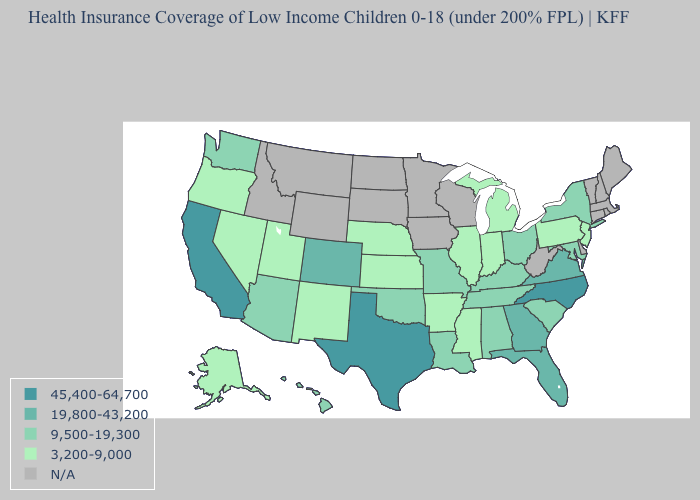How many symbols are there in the legend?
Short answer required. 5. What is the lowest value in the Northeast?
Be succinct. 3,200-9,000. Among the states that border Oklahoma , does Arkansas have the lowest value?
Quick response, please. Yes. Name the states that have a value in the range 3,200-9,000?
Short answer required. Alaska, Arkansas, Illinois, Indiana, Kansas, Michigan, Mississippi, Nebraska, Nevada, New Jersey, New Mexico, Oregon, Pennsylvania, Utah. Name the states that have a value in the range N/A?
Keep it brief. Connecticut, Delaware, Idaho, Iowa, Maine, Massachusetts, Minnesota, Montana, New Hampshire, North Dakota, Rhode Island, South Dakota, Vermont, West Virginia, Wisconsin, Wyoming. Which states hav the highest value in the Northeast?
Write a very short answer. New York. What is the value of North Dakota?
Be succinct. N/A. Does the map have missing data?
Keep it brief. Yes. How many symbols are there in the legend?
Answer briefly. 5. What is the value of Alaska?
Quick response, please. 3,200-9,000. Among the states that border Texas , which have the lowest value?
Concise answer only. Arkansas, New Mexico. Is the legend a continuous bar?
Give a very brief answer. No. Name the states that have a value in the range 45,400-64,700?
Quick response, please. California, North Carolina, Texas. Name the states that have a value in the range 3,200-9,000?
Be succinct. Alaska, Arkansas, Illinois, Indiana, Kansas, Michigan, Mississippi, Nebraska, Nevada, New Jersey, New Mexico, Oregon, Pennsylvania, Utah. What is the lowest value in states that border New Mexico?
Concise answer only. 3,200-9,000. 